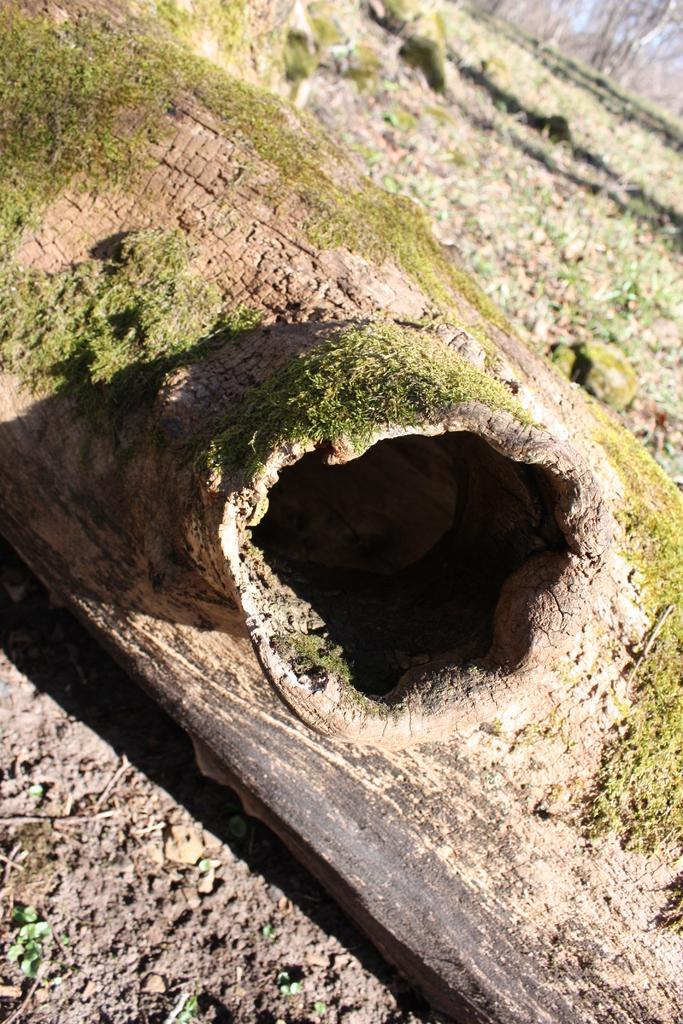How would you summarize this image in a sentence or two? In this image we can see a log on the ground. 